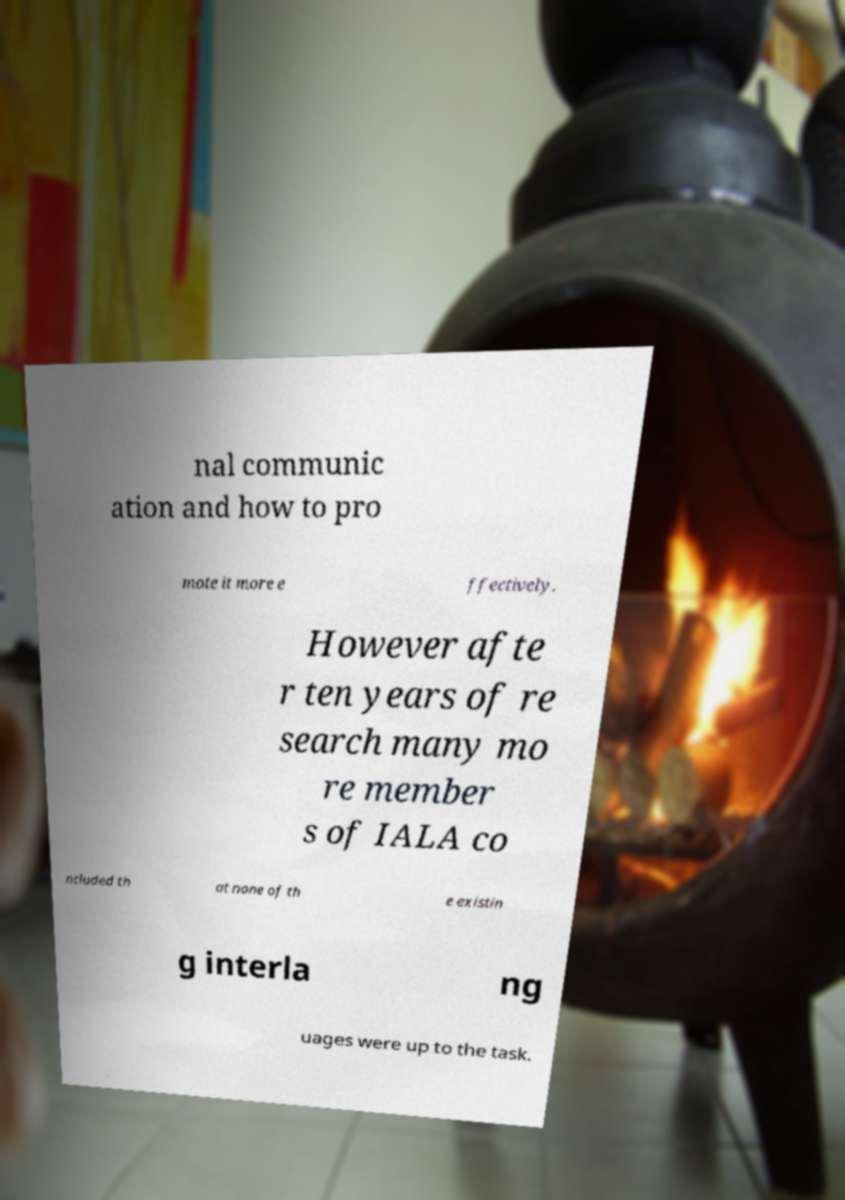For documentation purposes, I need the text within this image transcribed. Could you provide that? nal communic ation and how to pro mote it more e ffectively. However afte r ten years of re search many mo re member s of IALA co ncluded th at none of th e existin g interla ng uages were up to the task. 